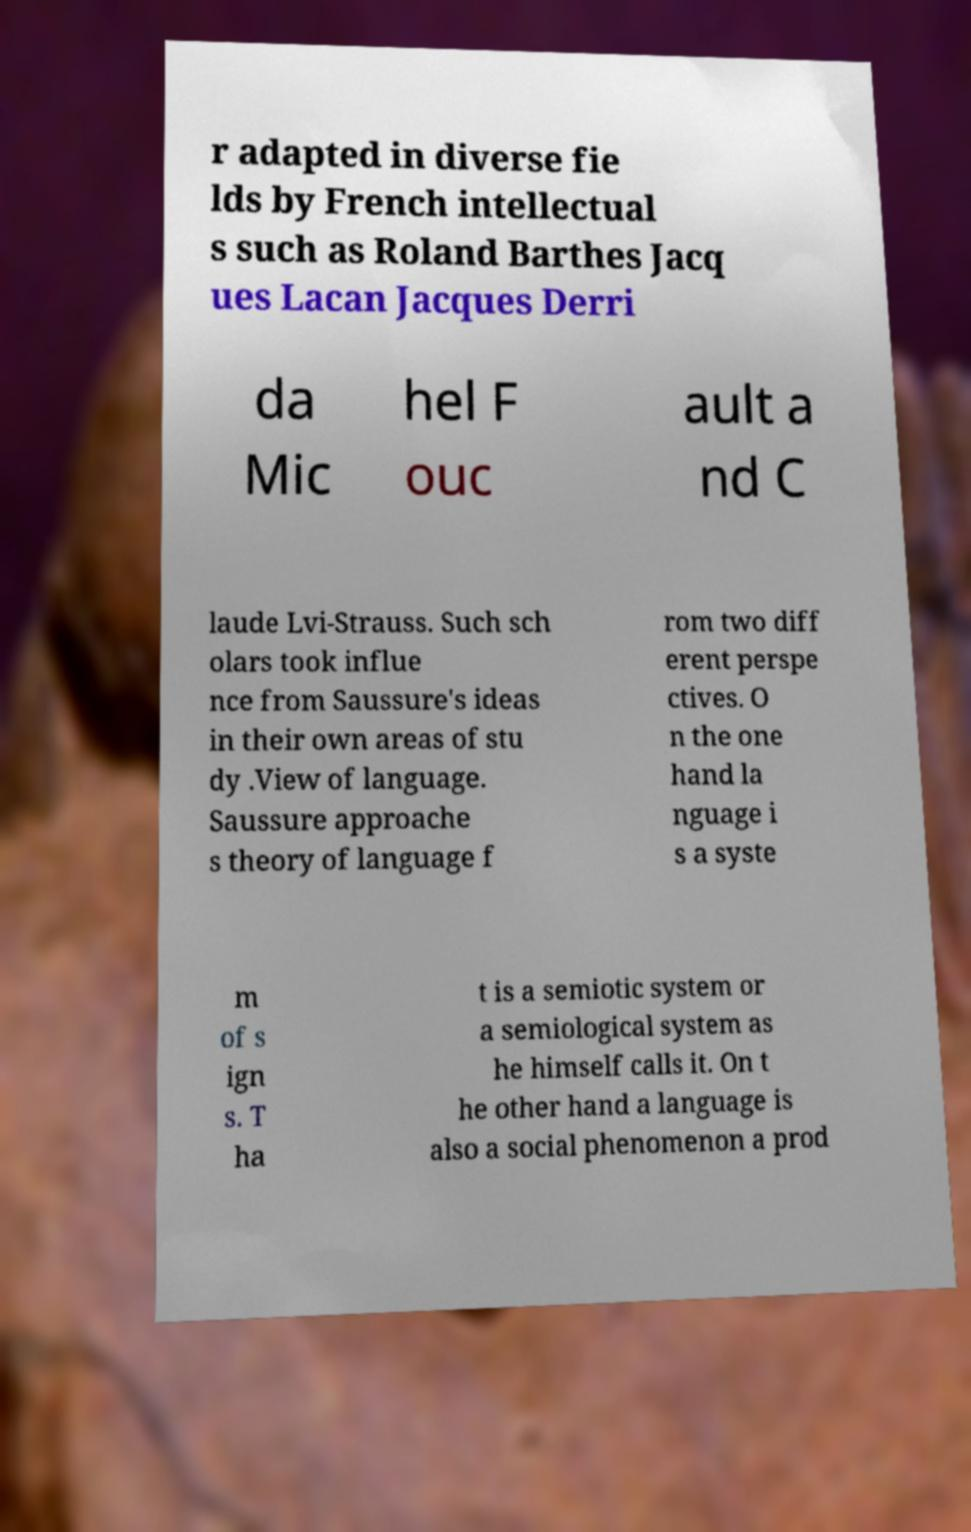I need the written content from this picture converted into text. Can you do that? r adapted in diverse fie lds by French intellectual s such as Roland Barthes Jacq ues Lacan Jacques Derri da Mic hel F ouc ault a nd C laude Lvi-Strauss. Such sch olars took influe nce from Saussure's ideas in their own areas of stu dy .View of language. Saussure approache s theory of language f rom two diff erent perspe ctives. O n the one hand la nguage i s a syste m of s ign s. T ha t is a semiotic system or a semiological system as he himself calls it. On t he other hand a language is also a social phenomenon a prod 